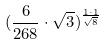Convert formula to latex. <formula><loc_0><loc_0><loc_500><loc_500>( \frac { 6 } { 2 6 8 } \cdot \sqrt { 3 } ) ^ { \frac { 1 \cdot 1 } { \sqrt { 8 } } }</formula> 